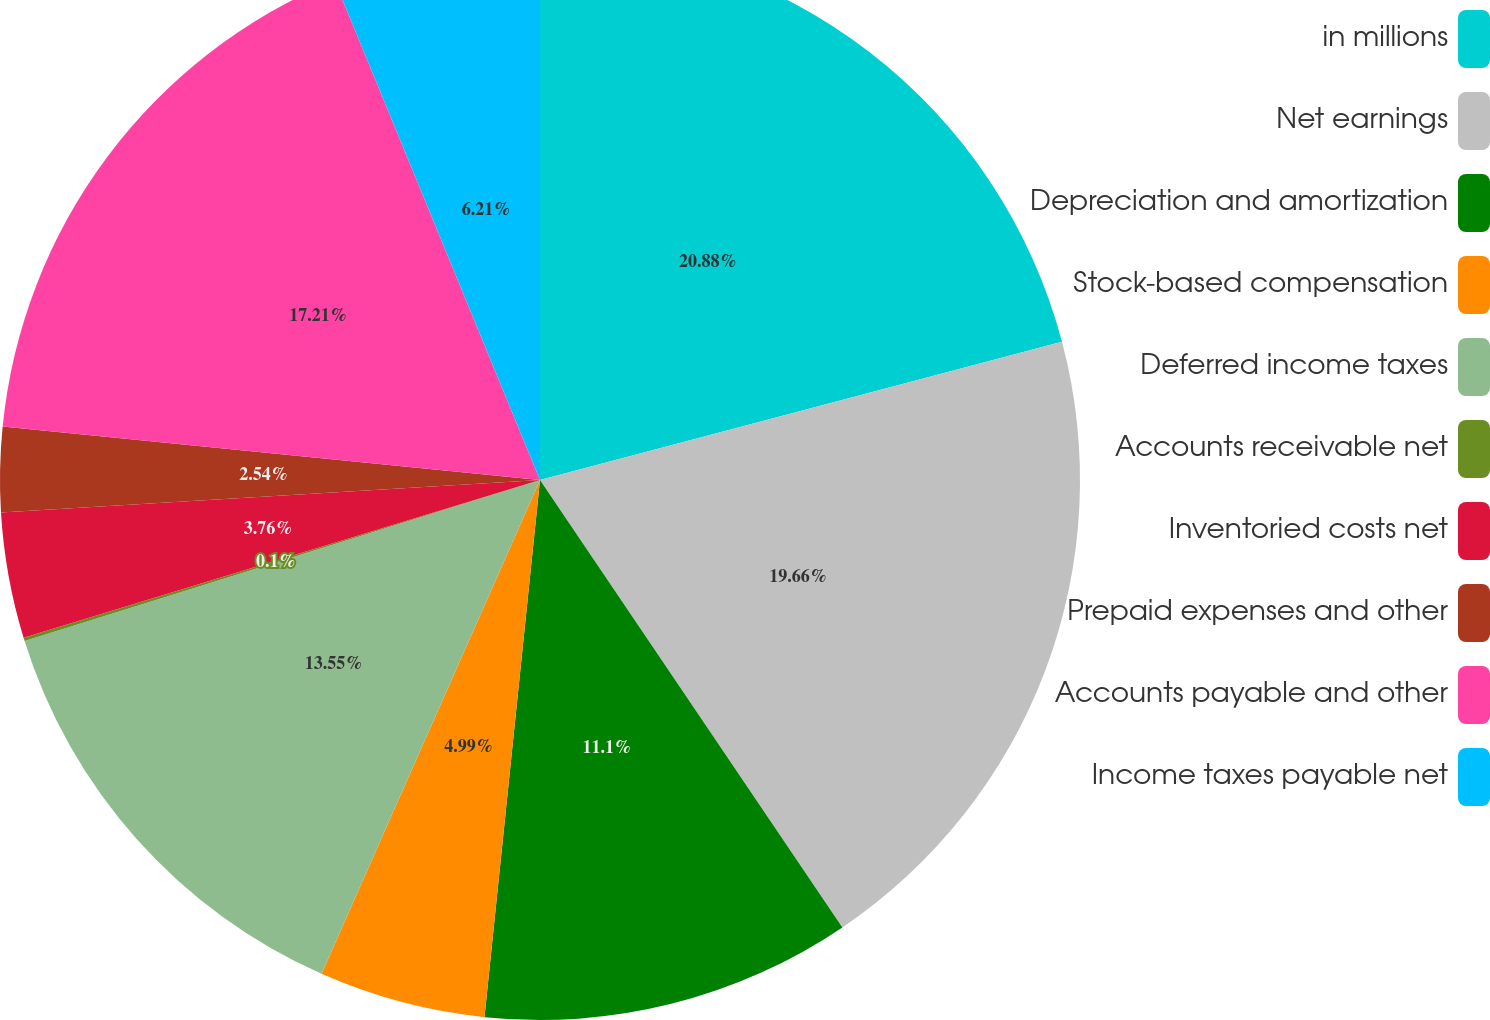Convert chart. <chart><loc_0><loc_0><loc_500><loc_500><pie_chart><fcel>in millions<fcel>Net earnings<fcel>Depreciation and amortization<fcel>Stock-based compensation<fcel>Deferred income taxes<fcel>Accounts receivable net<fcel>Inventoried costs net<fcel>Prepaid expenses and other<fcel>Accounts payable and other<fcel>Income taxes payable net<nl><fcel>20.88%<fcel>19.66%<fcel>11.1%<fcel>4.99%<fcel>13.55%<fcel>0.1%<fcel>3.76%<fcel>2.54%<fcel>17.21%<fcel>6.21%<nl></chart> 